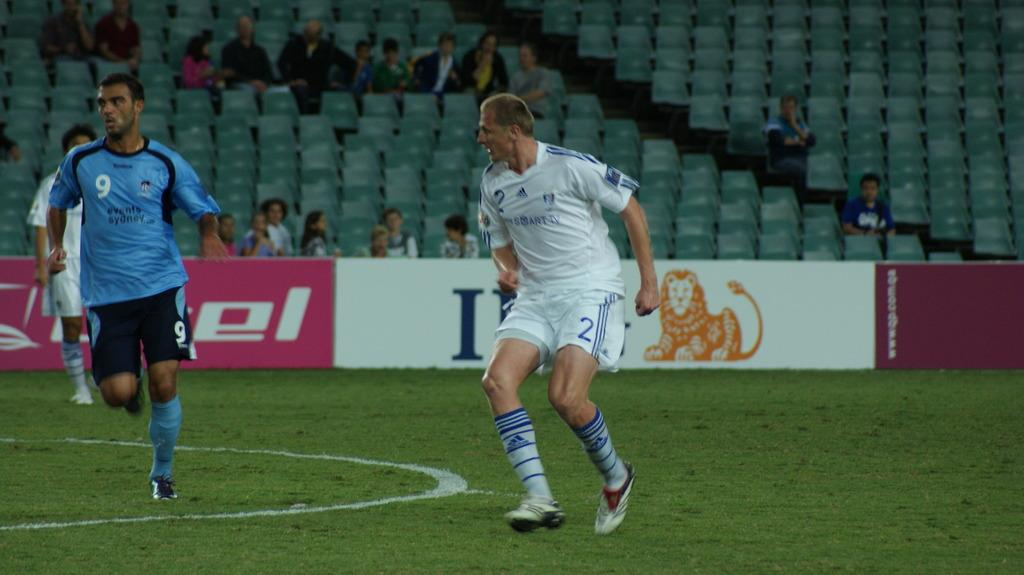<image>
Give a short and clear explanation of the subsequent image. A man in a blue Reebok shirt playing soccor. 